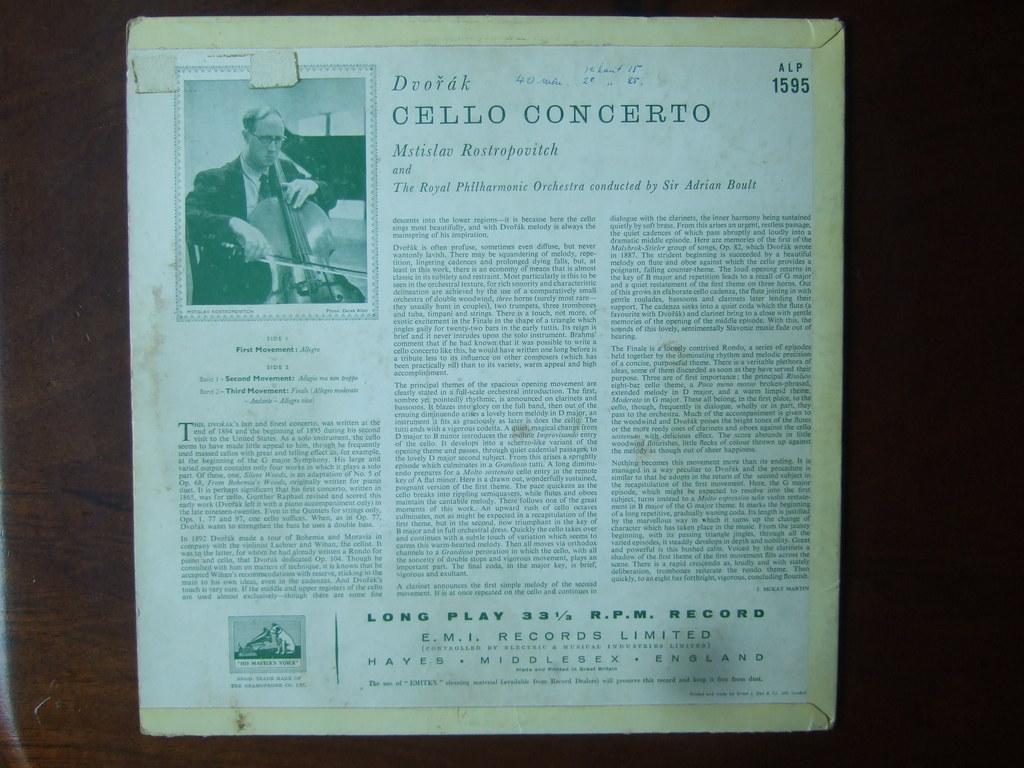Describe this image in one or two sentences. In this picture we can see an article of an editorial which is pasted on wall in which there is some text and we can see picture of a person. 